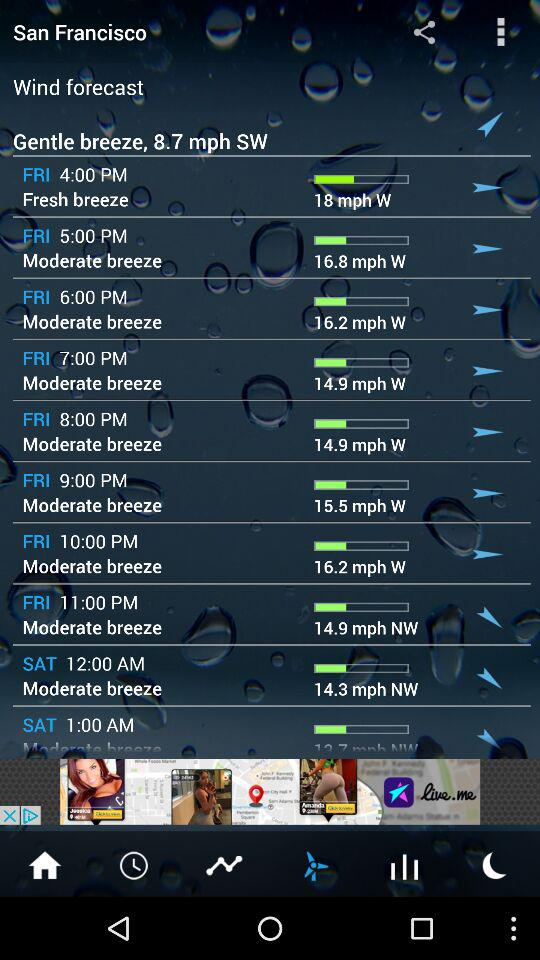What is the wind speed on Friday at 4 PM? The wind speed on Friday at 4 PM is 18 mph. 